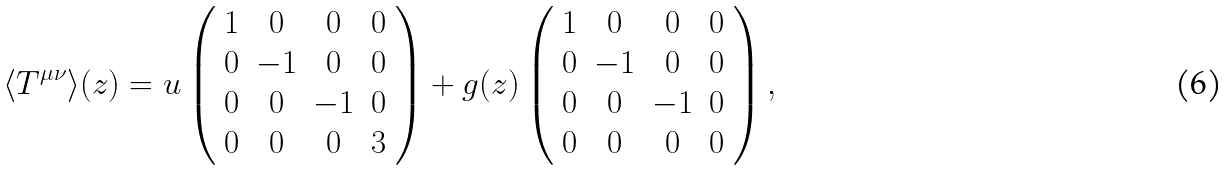<formula> <loc_0><loc_0><loc_500><loc_500>\langle T ^ { \mu \nu } \rangle ( z ) = u \left ( \begin{array} { c c c c } 1 & 0 & 0 & 0 \\ 0 & - 1 & 0 & 0 \\ 0 & 0 & - 1 & 0 \\ 0 & 0 & 0 & 3 \end{array} \right ) + g ( z ) \left ( \begin{array} { c c c c } 1 & 0 & 0 & 0 \\ 0 & - 1 & 0 & 0 \\ 0 & 0 & - 1 & 0 \\ 0 & 0 & 0 & 0 \end{array} \right ) ,</formula> 